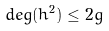Convert formula to latex. <formula><loc_0><loc_0><loc_500><loc_500>d e g ( h ^ { 2 } ) \leq 2 g</formula> 